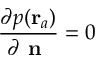<formula> <loc_0><loc_0><loc_500><loc_500>\frac { \partial p ( r _ { a } ) } { \partial n } = 0</formula> 